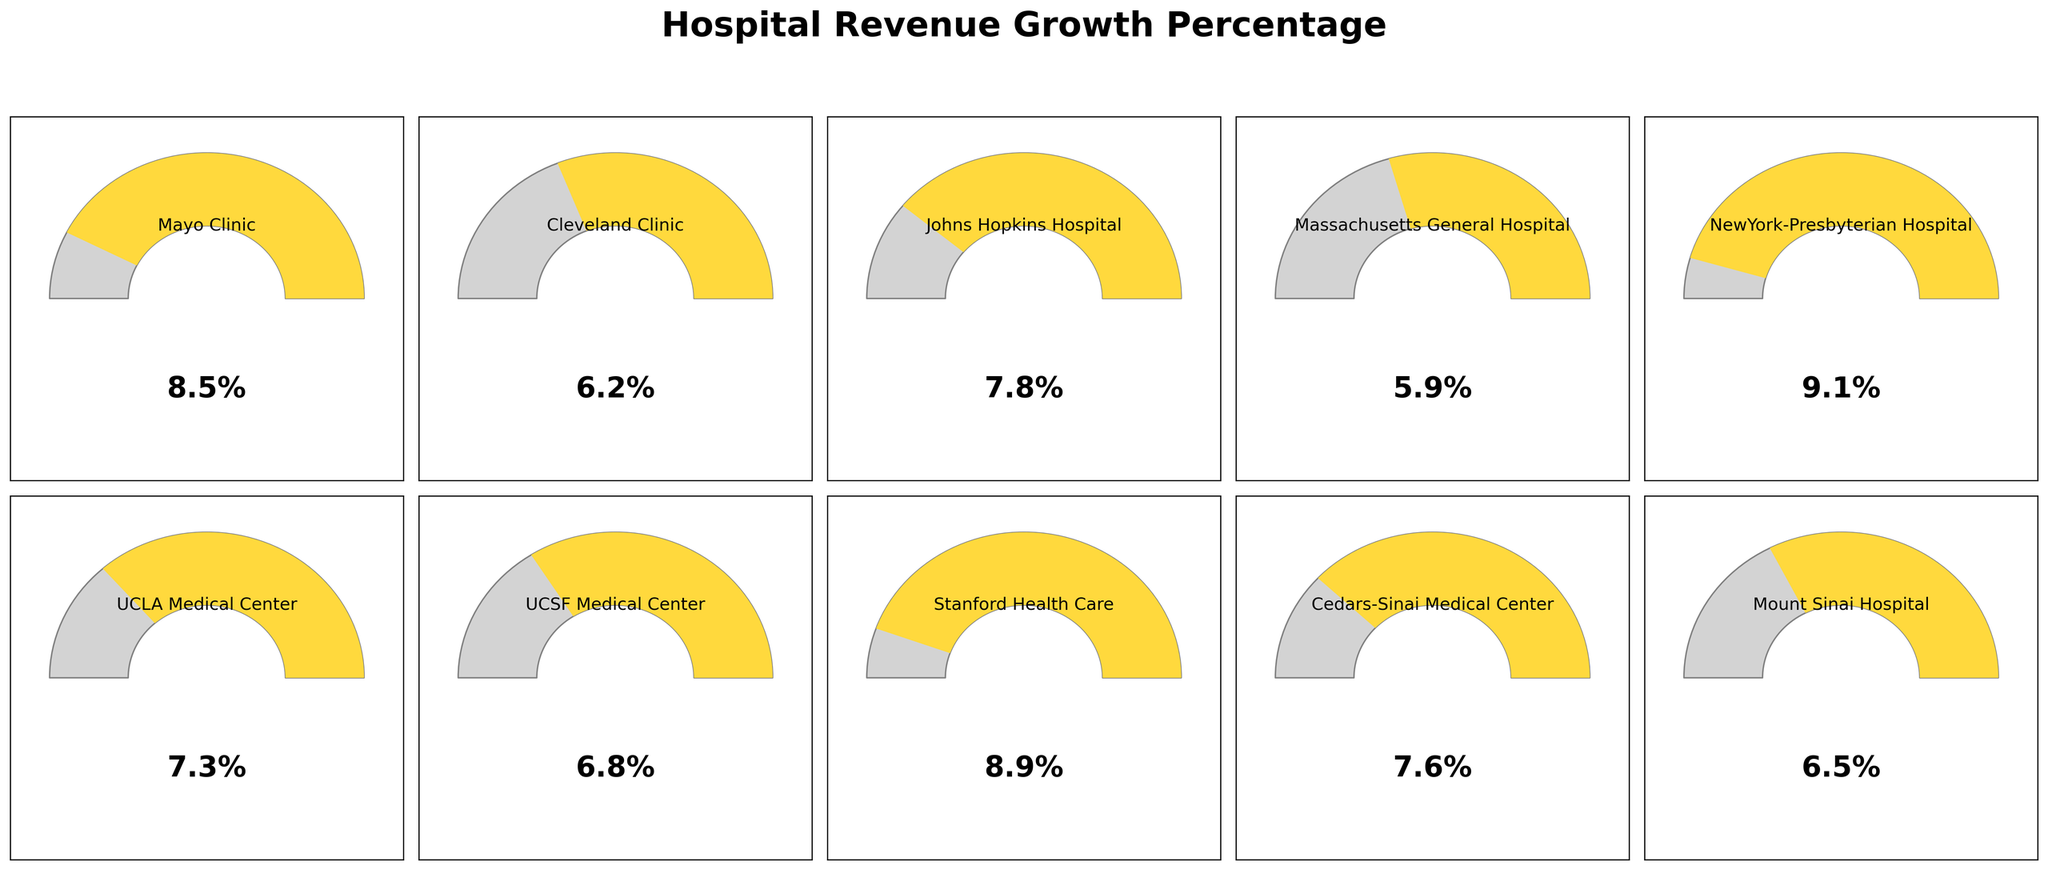What is the range of hospital revenue growth percentages shown in the plot? The plot shows various percentages. The hospital with the lowest revenue growth has 5.9%, and the hospital with the highest growth has 9.1%. So, the range is 9.1% - 5.9% = 3.2%.
Answer: 3.2% Which hospital has the highest revenue growth percentage? By observing the plot, NewYork-Presbyterian Hospital has the highest percentage of revenue growth at 9.1%.
Answer: NewYork-Presbyterian Hospital How many hospitals have a revenue growth percentage of 8% or more? Checking each gauge in the plot, Mayo Clinic (8.5%), Johns Hopkins Hospital (7.8%, just shy of 8%), Stanford Health Care (8.9%), and NewYork-Presbyterian Hospital (9.1%) meet or exceed 8%. There are 3 hospitals with >=8%.
Answer: 3 What is the average revenue growth percentage for the hospitals shown in the plot? Adding all visible percentages: 8.5 + 6.2 + 7.8 + 5.9 + 9.1 + 7.3 + 6.8 + 8.9 + 7.6 + 6.5 = 74.6. Then, divide by 10 (number of hospitals). 74.6 / 10 = 7.46%.
Answer: 7.46% What’s the second highest revenue growth percentage, and which hospital does it belong to? Identifying the highest, which is 9.1% (NewYork-Presbyterian Hospital), the next highest is 8.9% (Stanford Health Care).
Answer: 8.9% (Stanford Health Care) Which two hospitals have the closest revenue growth percentages, and what are their values? By comparing all adjacent values in the plot, UCSF Medical Center (6.8%) and Cedars-Sinai Medical Center (7.6%) have a difference of 0.8%, which is the smallest difference.
Answer: UCSF Medical Center (6.8%) and Cedars-Sinai Medical Center (7.6%) How do the revenue growth percentages compare between hospitals on the left (first 5 hospitals) and those on the right (last 5 hospitals)? Average of the first 5 are (8.5 + 6.2 + 7.8 + 5.9 + 9.1) / 5 = 7.5%. Average of the last 5 are (7.3 + 6.8 + 8.9 + 7.6 + 6.5) / 5 = 7.42%. The values are close, with the first 5 slightly higher.
Answer: Left: 7.5%, Right: 7.42% Which hospitals fall into the middle third (5%-10%) of revenue growth percentages based on the gauge coloring? Hospitals in the yellow gauge range (middle third) are all with revenue percentages over 5% and less than 10%. This includes all 10 hospitals.
Answer: All 10 Hospitals 